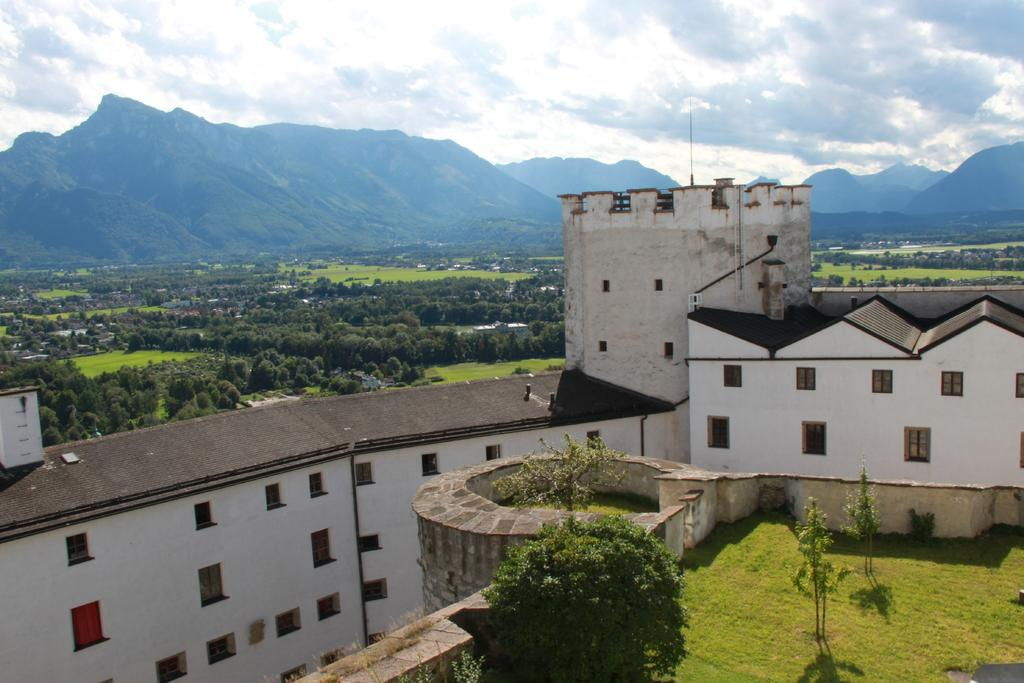What type of structure is present in the image? There is a building in the image. What features can be observed on the building? The building has windows. What natural elements are present around the building? There are trees and grass visible in the image. What type of vegetation is present in the image? There is a plant in the image. What geographical feature can be seen in the distance? There are mountains in the image. What is the weather like in the image? The sky is cloudy in the image. What caption is written on the building in the image? There is no caption visible on the building in the image. How many boys are playing in the grass in the image? There are no boys present in the image; it features a building, trees, grass, a plant, mountains, and a cloudy sky. 